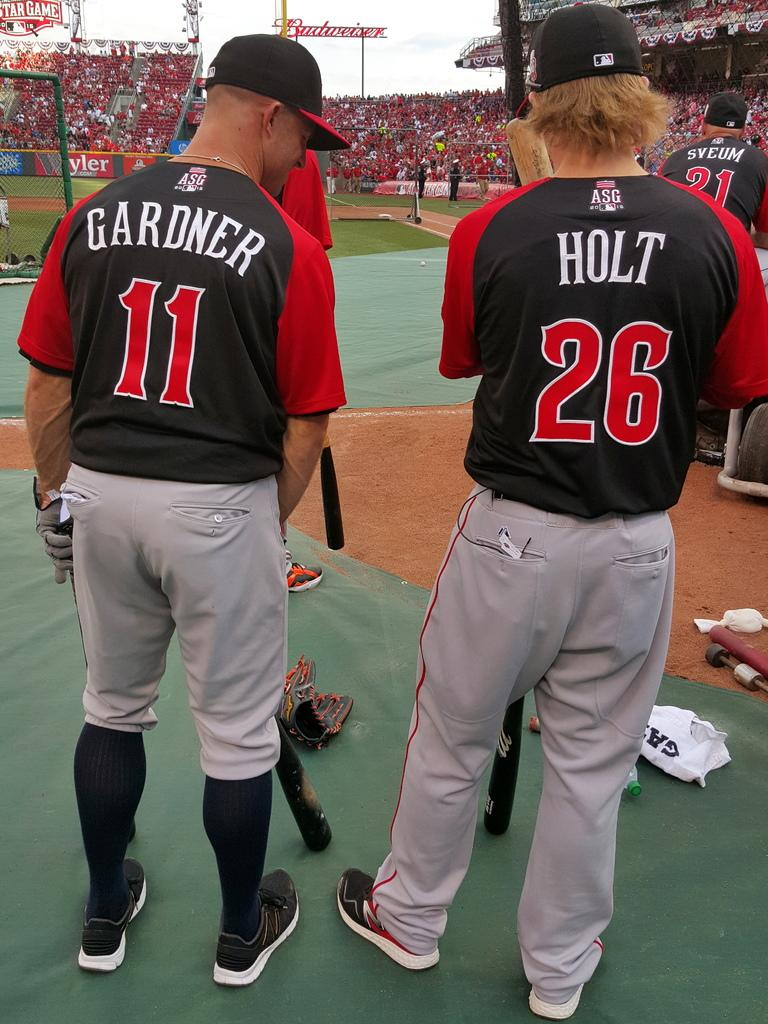<image>
Render a clear and concise summary of the photo. Two baseball players, Holt and Gardner, wait for their turn to bat. 